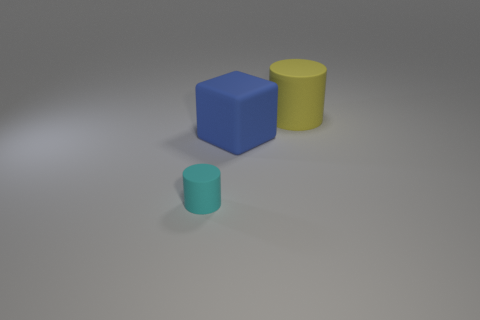Add 2 rubber blocks. How many objects exist? 5 Subtract all cylinders. How many objects are left? 1 Subtract all red metallic balls. Subtract all yellow rubber cylinders. How many objects are left? 2 Add 2 large yellow things. How many large yellow things are left? 3 Add 3 tiny gray metallic objects. How many tiny gray metallic objects exist? 3 Subtract 0 gray spheres. How many objects are left? 3 